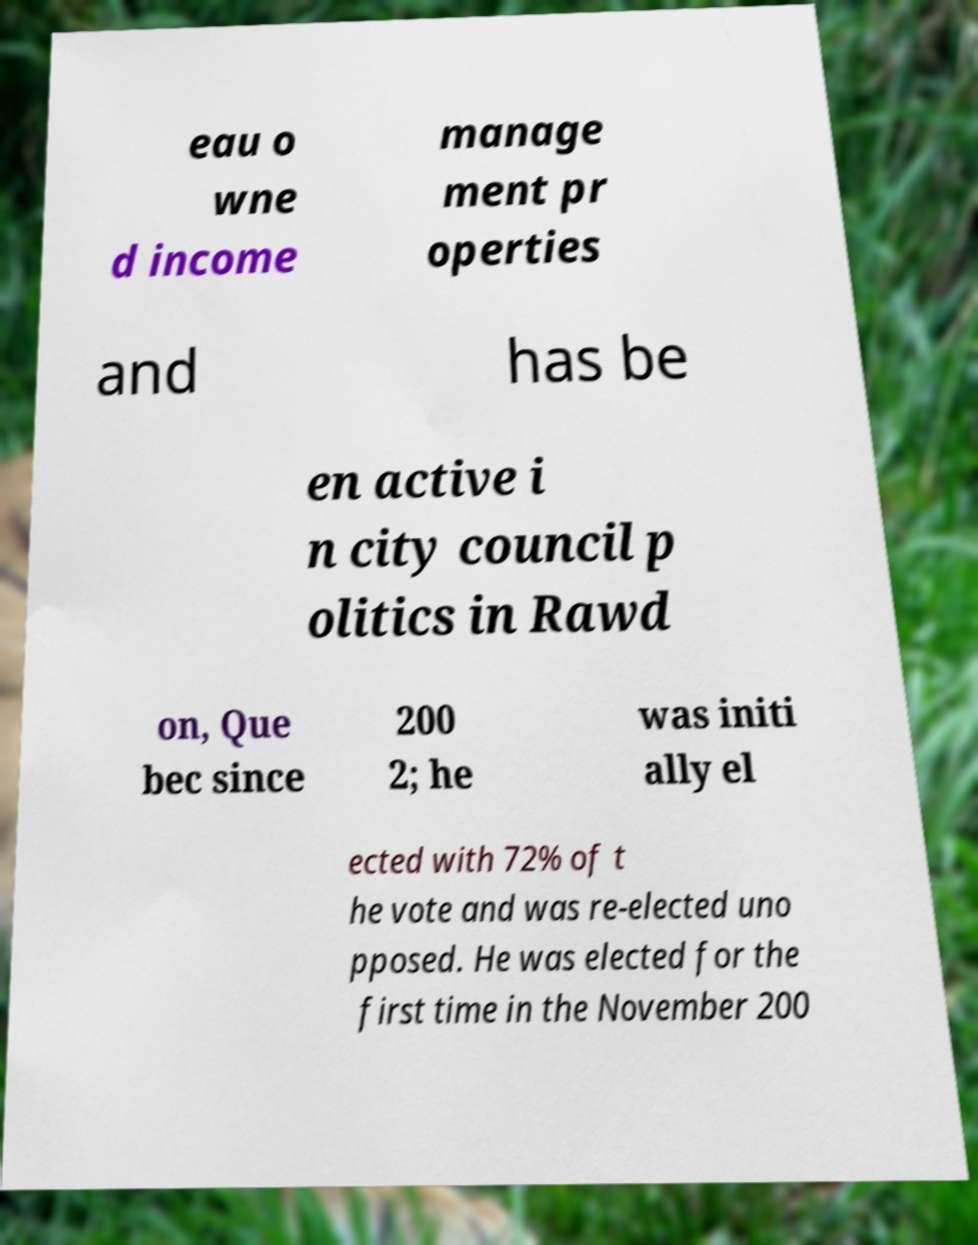Please read and relay the text visible in this image. What does it say? eau o wne d income manage ment pr operties and has be en active i n city council p olitics in Rawd on, Que bec since 200 2; he was initi ally el ected with 72% of t he vote and was re-elected uno pposed. He was elected for the first time in the November 200 